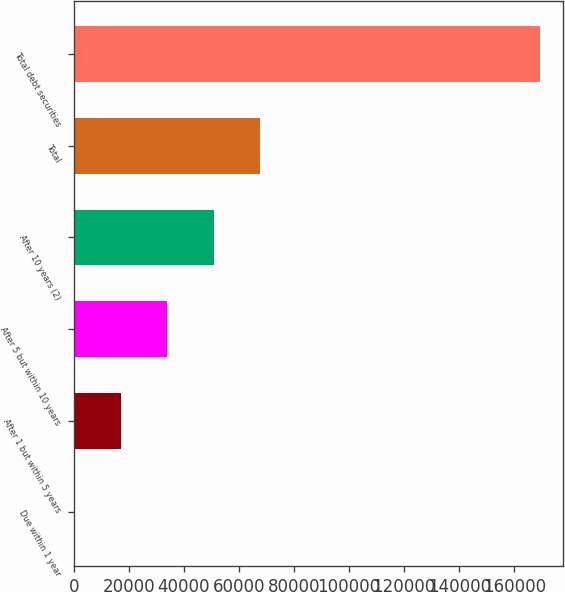Convert chart. <chart><loc_0><loc_0><loc_500><loc_500><bar_chart><fcel>Due within 1 year<fcel>After 1 but within 5 years<fcel>After 5 but within 10 years<fcel>After 10 years (2)<fcel>Total<fcel>Total debt securities<nl><fcel>80<fcel>17004.6<fcel>33929.2<fcel>50853.8<fcel>67778.4<fcel>169326<nl></chart> 